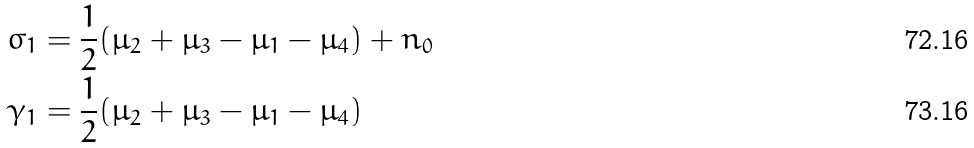<formula> <loc_0><loc_0><loc_500><loc_500>\sigma _ { 1 } & = \frac { 1 } { 2 } ( \mu _ { 2 } + \mu _ { 3 } - \mu _ { 1 } - \mu _ { 4 } ) + n _ { 0 } \\ \gamma _ { 1 } & = \frac { 1 } { 2 } ( \mu _ { 2 } + \mu _ { 3 } - \mu _ { 1 } - \mu _ { 4 } )</formula> 